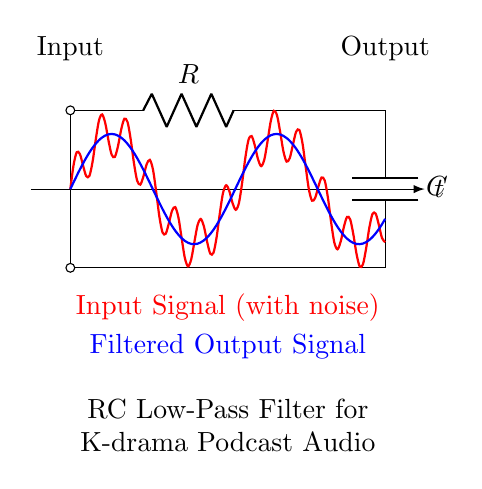What components are present in this circuit? The circuit includes a resistor and a capacitor, identified by the labels R and C, respectively.
Answer: Resistor and capacitor What type of filter is represented in this circuit? This circuit is an RC low-pass filter, which allows low-frequency signals to pass while attenuating higher frequency signals.
Answer: Low-pass filter What is the function of the resistor in this circuit? The resistor limits the amount of current flowing through the circuit, which is essential for controlling the charging and discharging of the capacitor.
Answer: Current limiting What is the significance of the input signal's two components? The input signal consists of a desired low-frequency signal (red) and unwanted high-frequency noise, illustrated by the additional sine wave. The low-pass filter then processes this input, minimizing the noise.
Answer: Noise reduction What is the expected output of this RC low-pass filter? The output will be a smoothed version of the input signal, primarily containing the low-frequency components while filtering out high-frequency noise.
Answer: Filtered output How does changing the values of R and C affect the filter's performance? Increasing the resistance R or the capacitance C decreases the cutoff frequency of the low-pass filter, resulting in more significant attenuation of high frequencies, thereby altering the filter's response to various signal frequencies.
Answer: Alters cutoff frequency What is the effect of this filter on audio recordings of K-drama analysis podcasts? This filter enhances audio clarity by reducing background noise, allowing dialogue and sound effects to be more prominent and clear for listeners.
Answer: Enhances audio clarity 